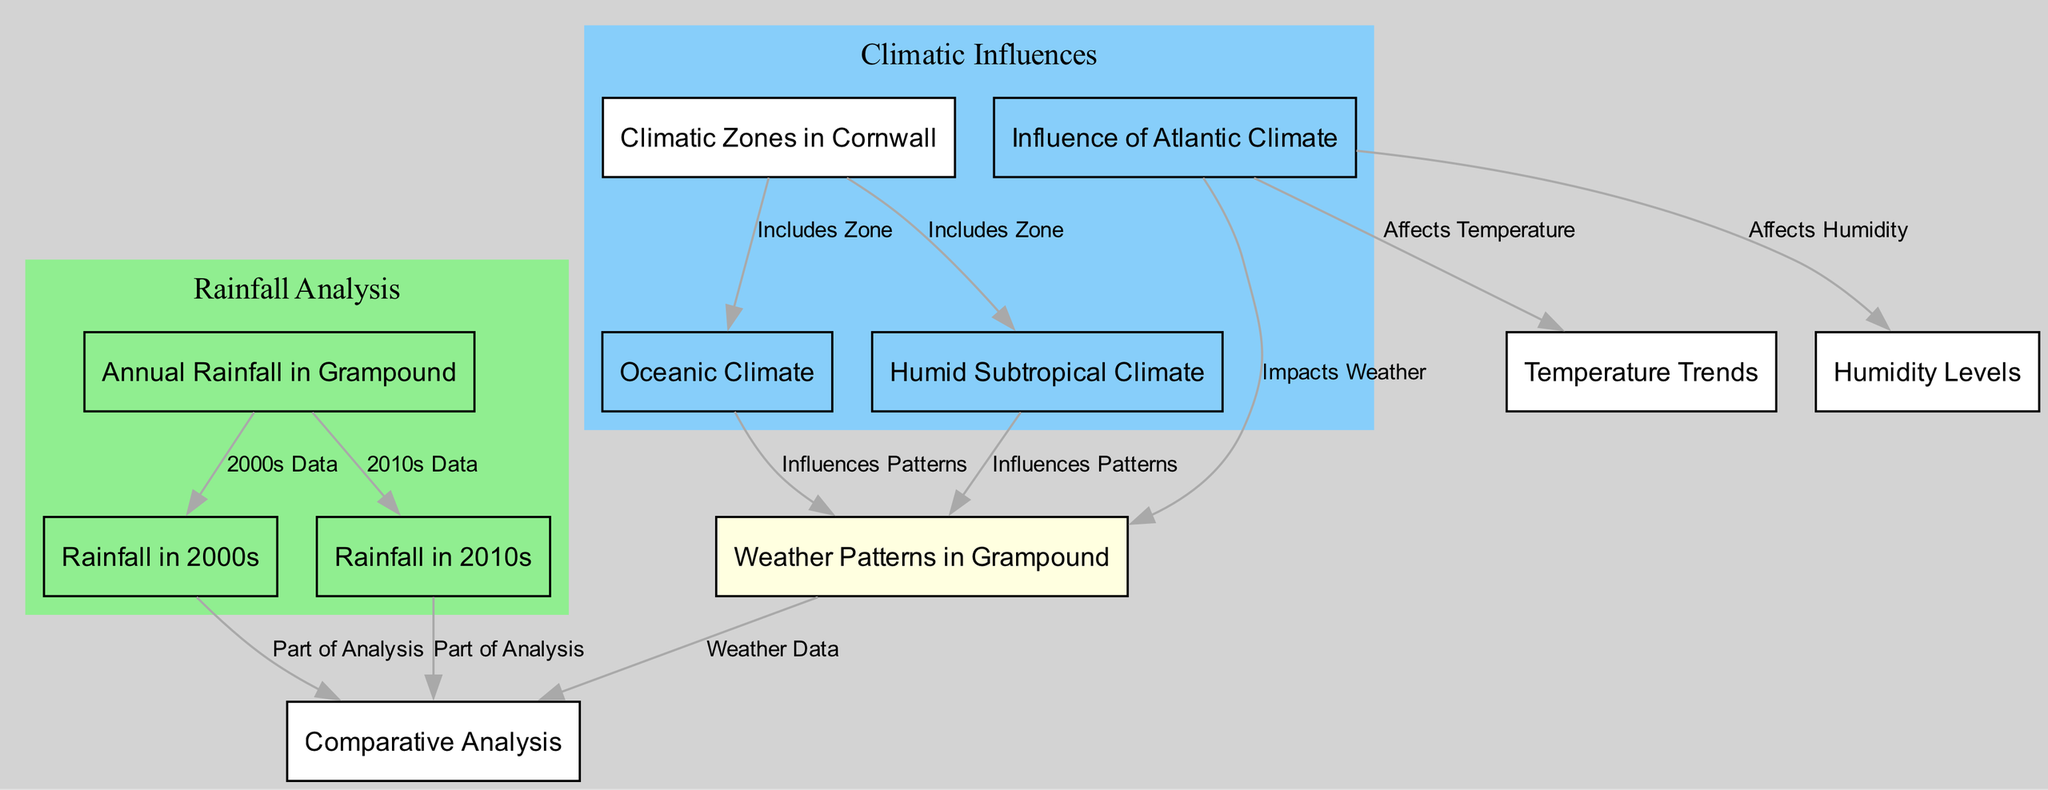What is the primary focus of the diagram? The diagram primarily focuses on the analysis of annual rainfall and weather patterns in Grampound over two decades, segmented by climatic zones.
Answer: Annual rainfall and weather patterns in Grampound Which climatic zones are included in the diagram? The diagram includes two climatic zones: Oceanic Climate and Humid Subtropical Climate. This can be deduced from the nodes labeled under Cornwall Climatic Zones.
Answer: Oceanic Climate and Humid Subtropical Climate How many nodes represent rainfall data in the diagram? There are three nodes that specifically represent rainfall data: 'Annual Rainfall in Grampound', 'Rainfall in 2000s', and 'Rainfall in 2010s'.
Answer: Three What influences the weather patterns in Grampound? The weather patterns in Grampound are influenced by both the Oceanic Climate and the Humid Subtropical Climate as indicated by the connections leading to the 'Weather Patterns in Grampound' node.
Answer: Oceanic Climate and Humid Subtropical Climate What is the relationship between Atlantic Climate Influence and Temperature Trends? The diagram indicates a direct relationship where the Influence of Atlantic Climate affects Temperature Trends, illustrating the impact of this climatic factor on temperature variations.
Answer: Affects Temperature How do the rainfall data from the 2000s and 2010s contribute to the analysis? The rainfall data from both decades contribute as parts of the comparative analysis, allowing for insights into changes in rainfall patterns over time.
Answer: Part of Analysis Which node has the most connections in the diagram? The node 'Weather Patterns in Grampound' has the most connections, interfacing with both rainfall data and climatic influences, highlighting its central role in the analysis.
Answer: Weather Patterns in Grampound Which type of climate has a stated influence on humidity levels? The diagram states that the Influence of Atlantic Climate affects Humidity Levels, indicating its role as a climatic factor impacting local humidity.
Answer: Atlantic Climate Influence 